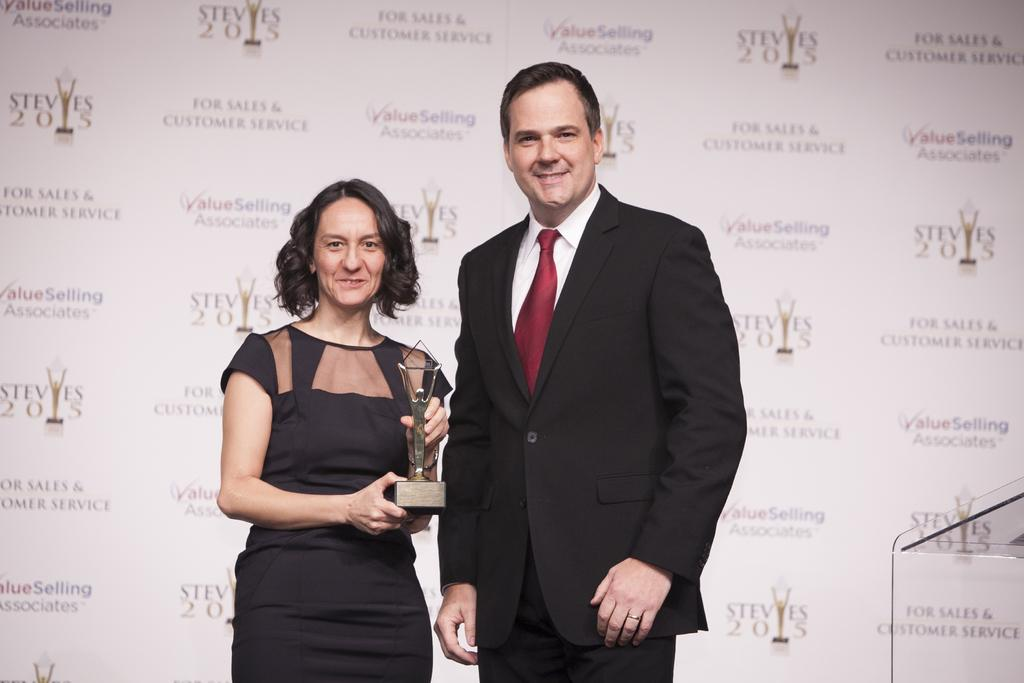Who are the people in the image? There is a lady and a man standing in the image. What is the lady holding in the image? The lady is holding a trophy. What can be seen in the background of the image? There is wallpaper in the background of the image. Where does the scene take place? The scene takes place on a podium. What type of leather is used to make the trophy in the image? There is no leather used to make the trophy in the image; it is likely made of metal, glass, or another material. 